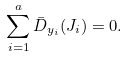<formula> <loc_0><loc_0><loc_500><loc_500>\sum _ { i = 1 } ^ { a } \bar { D } _ { y _ { i } } ( J _ { i } ) = 0 .</formula> 